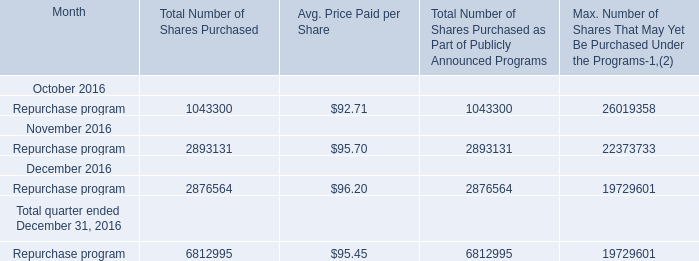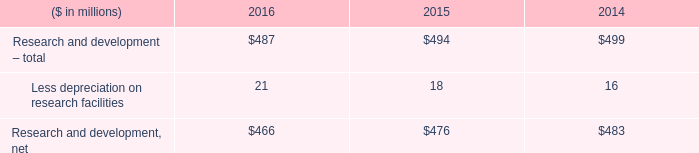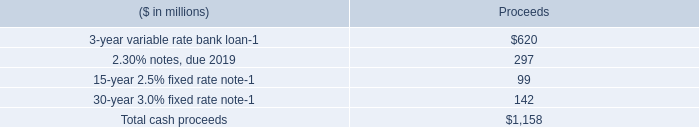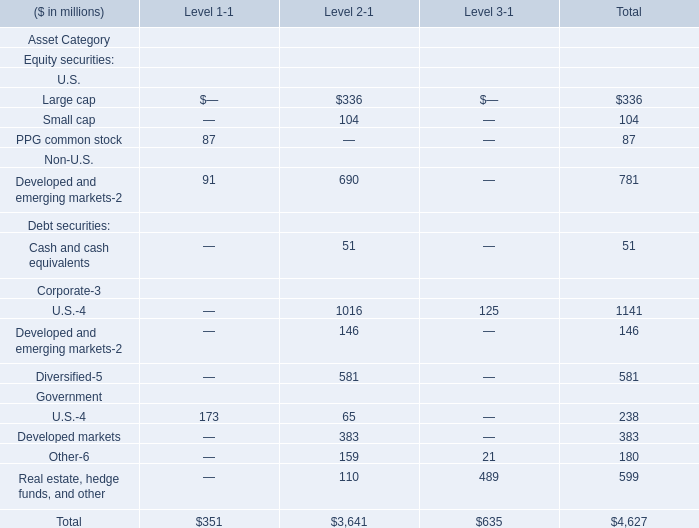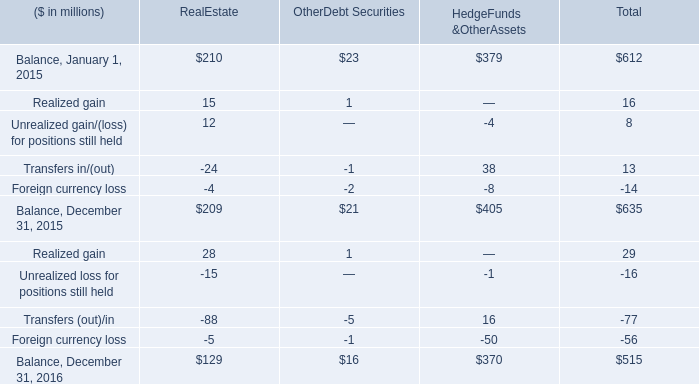What do all OtherDebt Securities sum up, excluding those negative ones in 2015? (in million) 
Computations: (((23 + 1) + 21) + 1)
Answer: 46.0. 